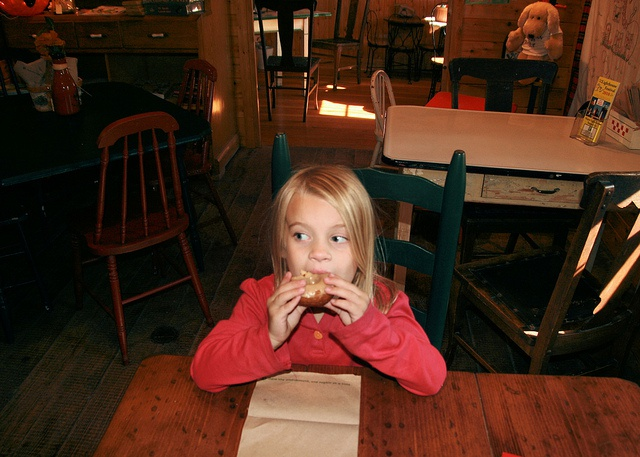Describe the objects in this image and their specific colors. I can see dining table in maroon and tan tones, people in maroon, brown, tan, and red tones, chair in maroon, black, and tan tones, dining table in maroon, salmon, brown, and black tones, and chair in black, maroon, and gray tones in this image. 